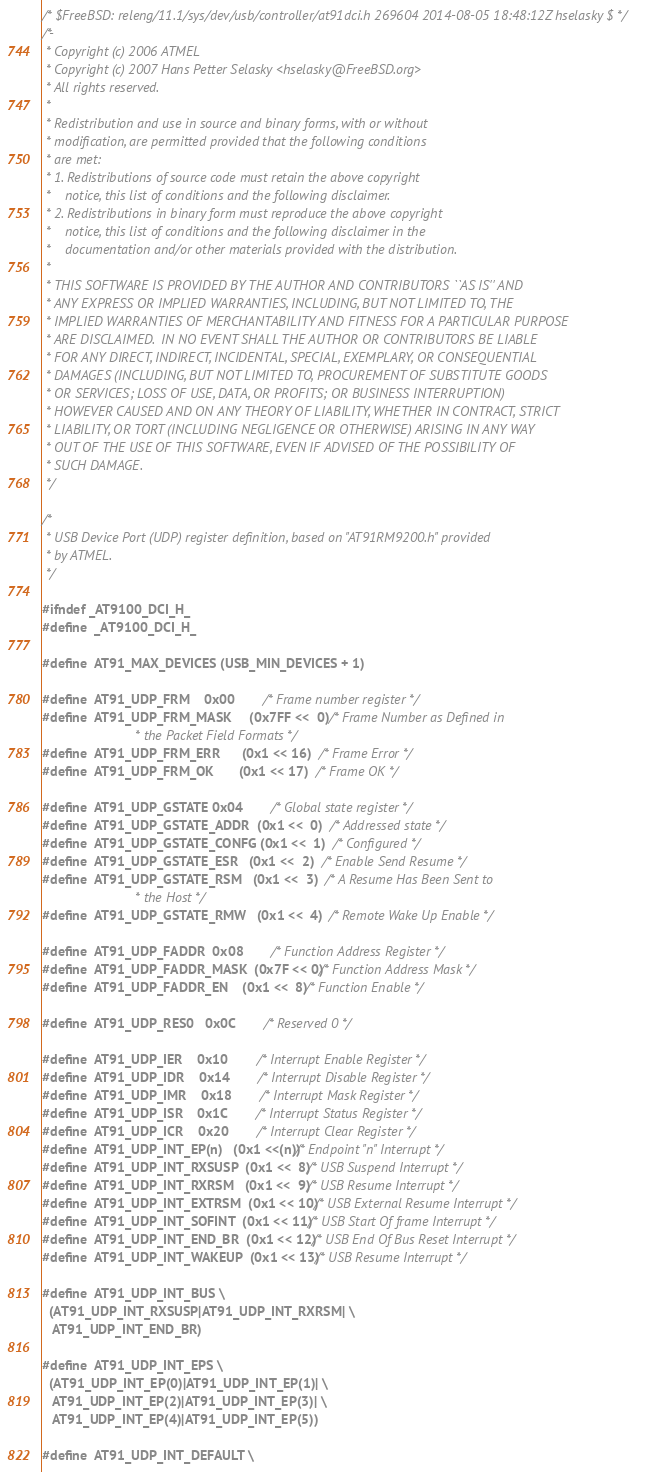Convert code to text. <code><loc_0><loc_0><loc_500><loc_500><_C_>/* $FreeBSD: releng/11.1/sys/dev/usb/controller/at91dci.h 269604 2014-08-05 18:48:12Z hselasky $ */
/*-
 * Copyright (c) 2006 ATMEL
 * Copyright (c) 2007 Hans Petter Selasky <hselasky@FreeBSD.org>
 * All rights reserved.
 *
 * Redistribution and use in source and binary forms, with or without
 * modification, are permitted provided that the following conditions
 * are met:
 * 1. Redistributions of source code must retain the above copyright
 *    notice, this list of conditions and the following disclaimer.
 * 2. Redistributions in binary form must reproduce the above copyright
 *    notice, this list of conditions and the following disclaimer in the
 *    documentation and/or other materials provided with the distribution.
 *
 * THIS SOFTWARE IS PROVIDED BY THE AUTHOR AND CONTRIBUTORS ``AS IS'' AND
 * ANY EXPRESS OR IMPLIED WARRANTIES, INCLUDING, BUT NOT LIMITED TO, THE
 * IMPLIED WARRANTIES OF MERCHANTABILITY AND FITNESS FOR A PARTICULAR PURPOSE
 * ARE DISCLAIMED.  IN NO EVENT SHALL THE AUTHOR OR CONTRIBUTORS BE LIABLE
 * FOR ANY DIRECT, INDIRECT, INCIDENTAL, SPECIAL, EXEMPLARY, OR CONSEQUENTIAL
 * DAMAGES (INCLUDING, BUT NOT LIMITED TO, PROCUREMENT OF SUBSTITUTE GOODS
 * OR SERVICES; LOSS OF USE, DATA, OR PROFITS; OR BUSINESS INTERRUPTION)
 * HOWEVER CAUSED AND ON ANY THEORY OF LIABILITY, WHETHER IN CONTRACT, STRICT
 * LIABILITY, OR TORT (INCLUDING NEGLIGENCE OR OTHERWISE) ARISING IN ANY WAY
 * OUT OF THE USE OF THIS SOFTWARE, EVEN IF ADVISED OF THE POSSIBILITY OF
 * SUCH DAMAGE.
 */

/*
 * USB Device Port (UDP) register definition, based on "AT91RM9200.h" provided
 * by ATMEL.
 */

#ifndef _AT9100_DCI_H_
#define	_AT9100_DCI_H_

#define	AT91_MAX_DEVICES (USB_MIN_DEVICES + 1)

#define	AT91_UDP_FRM 	0x00		/* Frame number register */
#define	AT91_UDP_FRM_MASK     (0x7FF <<  0)	/* Frame Number as Defined in
						 * the Packet Field Formats */
#define	AT91_UDP_FRM_ERR      (0x1 << 16)	/* Frame Error */
#define	AT91_UDP_FRM_OK       (0x1 << 17)	/* Frame OK */

#define	AT91_UDP_GSTATE 0x04		/* Global state register */
#define	AT91_UDP_GSTATE_ADDR  (0x1 <<  0)	/* Addressed state */
#define	AT91_UDP_GSTATE_CONFG (0x1 <<  1)	/* Configured */
#define	AT91_UDP_GSTATE_ESR   (0x1 <<  2)	/* Enable Send Resume */
#define	AT91_UDP_GSTATE_RSM   (0x1 <<  3)	/* A Resume Has Been Sent to
						 * the Host */
#define	AT91_UDP_GSTATE_RMW   (0x1 <<  4)	/* Remote Wake Up Enable */

#define	AT91_UDP_FADDR	0x08		/* Function Address Register */
#define	AT91_UDP_FADDR_MASK  (0x7F << 0)/* Function Address Mask */
#define	AT91_UDP_FADDR_EN    (0x1 <<  8)/* Function Enable */

#define	AT91_UDP_RES0	0x0C		/* Reserved 0 */

#define	AT91_UDP_IER	0x10		/* Interrupt Enable Register */
#define	AT91_UDP_IDR	0x14		/* Interrupt Disable Register */
#define	AT91_UDP_IMR	0x18		/* Interrupt Mask Register */
#define	AT91_UDP_ISR	0x1C		/* Interrupt Status Register */
#define	AT91_UDP_ICR	0x20		/* Interrupt Clear Register */
#define	AT91_UDP_INT_EP(n)   (0x1 <<(n))/* Endpoint "n" Interrupt */
#define	AT91_UDP_INT_RXSUSP  (0x1 <<  8)/* USB Suspend Interrupt */
#define	AT91_UDP_INT_RXRSM   (0x1 <<  9)/* USB Resume Interrupt */
#define	AT91_UDP_INT_EXTRSM  (0x1 << 10)/* USB External Resume Interrupt */
#define	AT91_UDP_INT_SOFINT  (0x1 << 11)/* USB Start Of frame Interrupt */
#define	AT91_UDP_INT_END_BR  (0x1 << 12)/* USB End Of Bus Reset Interrupt */
#define	AT91_UDP_INT_WAKEUP  (0x1 << 13)/* USB Resume Interrupt */

#define	AT91_UDP_INT_BUS \
  (AT91_UDP_INT_RXSUSP|AT91_UDP_INT_RXRSM| \
   AT91_UDP_INT_END_BR)

#define	AT91_UDP_INT_EPS \
  (AT91_UDP_INT_EP(0)|AT91_UDP_INT_EP(1)| \
   AT91_UDP_INT_EP(2)|AT91_UDP_INT_EP(3)| \
   AT91_UDP_INT_EP(4)|AT91_UDP_INT_EP(5))

#define	AT91_UDP_INT_DEFAULT \</code> 